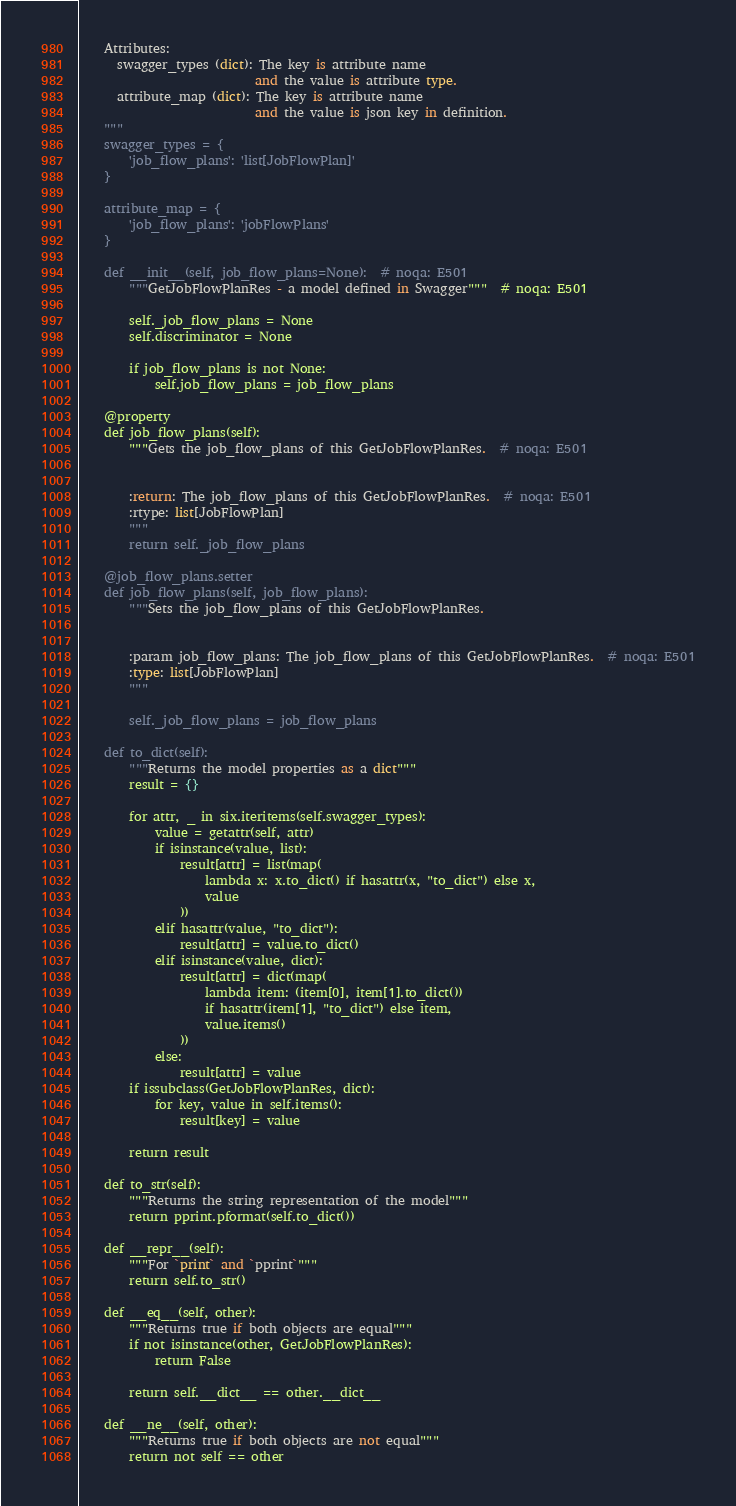<code> <loc_0><loc_0><loc_500><loc_500><_Python_>    Attributes:
      swagger_types (dict): The key is attribute name
                            and the value is attribute type.
      attribute_map (dict): The key is attribute name
                            and the value is json key in definition.
    """
    swagger_types = {
        'job_flow_plans': 'list[JobFlowPlan]'
    }

    attribute_map = {
        'job_flow_plans': 'jobFlowPlans'
    }

    def __init__(self, job_flow_plans=None):  # noqa: E501
        """GetJobFlowPlanRes - a model defined in Swagger"""  # noqa: E501

        self._job_flow_plans = None
        self.discriminator = None

        if job_flow_plans is not None:
            self.job_flow_plans = job_flow_plans

    @property
    def job_flow_plans(self):
        """Gets the job_flow_plans of this GetJobFlowPlanRes.  # noqa: E501


        :return: The job_flow_plans of this GetJobFlowPlanRes.  # noqa: E501
        :rtype: list[JobFlowPlan]
        """
        return self._job_flow_plans

    @job_flow_plans.setter
    def job_flow_plans(self, job_flow_plans):
        """Sets the job_flow_plans of this GetJobFlowPlanRes.


        :param job_flow_plans: The job_flow_plans of this GetJobFlowPlanRes.  # noqa: E501
        :type: list[JobFlowPlan]
        """

        self._job_flow_plans = job_flow_plans

    def to_dict(self):
        """Returns the model properties as a dict"""
        result = {}

        for attr, _ in six.iteritems(self.swagger_types):
            value = getattr(self, attr)
            if isinstance(value, list):
                result[attr] = list(map(
                    lambda x: x.to_dict() if hasattr(x, "to_dict") else x,
                    value
                ))
            elif hasattr(value, "to_dict"):
                result[attr] = value.to_dict()
            elif isinstance(value, dict):
                result[attr] = dict(map(
                    lambda item: (item[0], item[1].to_dict())
                    if hasattr(item[1], "to_dict") else item,
                    value.items()
                ))
            else:
                result[attr] = value
        if issubclass(GetJobFlowPlanRes, dict):
            for key, value in self.items():
                result[key] = value

        return result

    def to_str(self):
        """Returns the string representation of the model"""
        return pprint.pformat(self.to_dict())

    def __repr__(self):
        """For `print` and `pprint`"""
        return self.to_str()

    def __eq__(self, other):
        """Returns true if both objects are equal"""
        if not isinstance(other, GetJobFlowPlanRes):
            return False

        return self.__dict__ == other.__dict__

    def __ne__(self, other):
        """Returns true if both objects are not equal"""
        return not self == other
</code> 